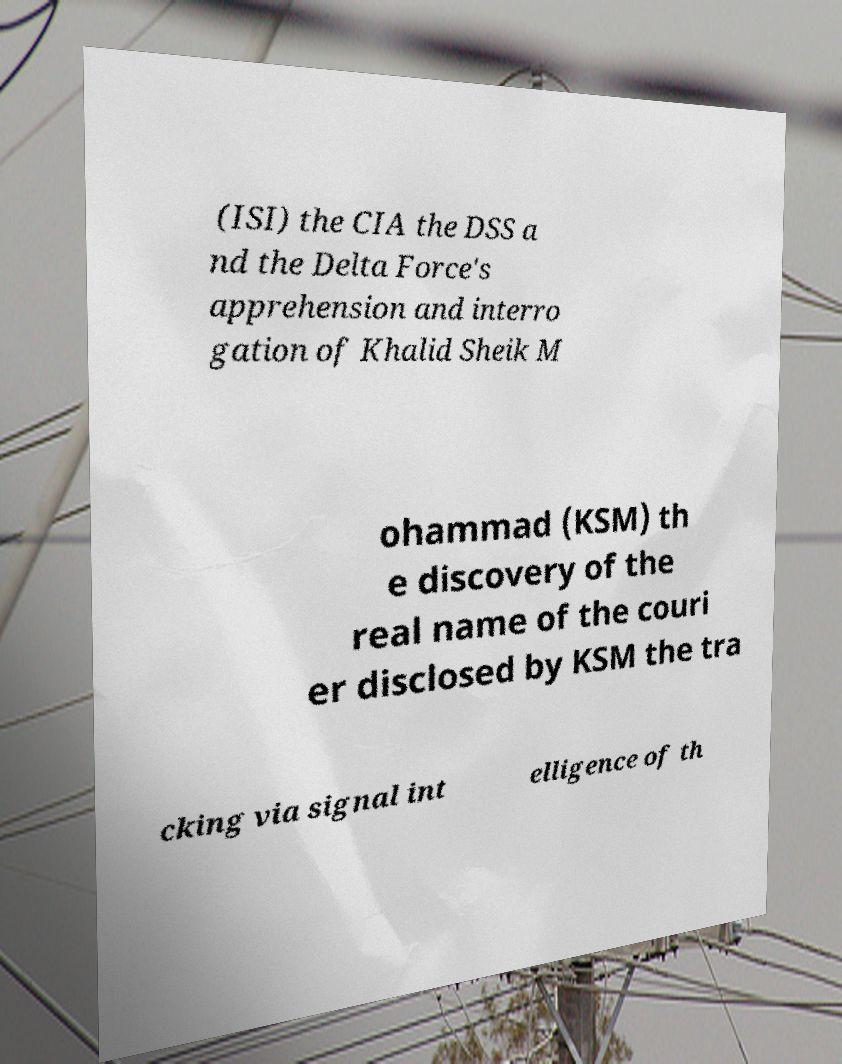Please read and relay the text visible in this image. What does it say? (ISI) the CIA the DSS a nd the Delta Force's apprehension and interro gation of Khalid Sheik M ohammad (KSM) th e discovery of the real name of the couri er disclosed by KSM the tra cking via signal int elligence of th 